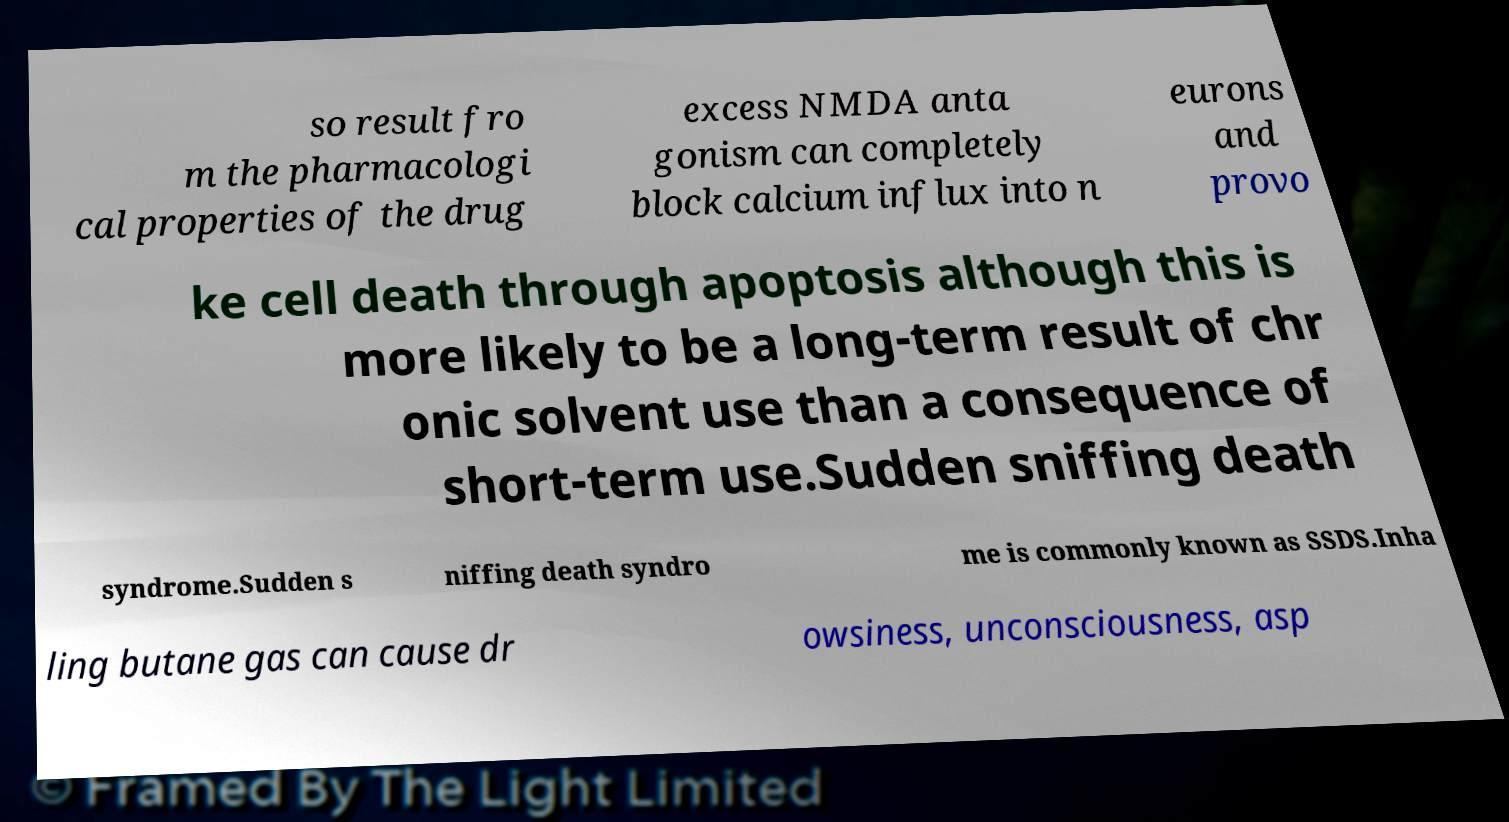Please read and relay the text visible in this image. What does it say? so result fro m the pharmacologi cal properties of the drug excess NMDA anta gonism can completely block calcium influx into n eurons and provo ke cell death through apoptosis although this is more likely to be a long-term result of chr onic solvent use than a consequence of short-term use.Sudden sniffing death syndrome.Sudden s niffing death syndro me is commonly known as SSDS.Inha ling butane gas can cause dr owsiness, unconsciousness, asp 